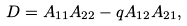<formula> <loc_0><loc_0><loc_500><loc_500>D = A _ { 1 1 } A _ { 2 2 } - q A _ { 1 2 } A _ { 2 1 } ,</formula> 